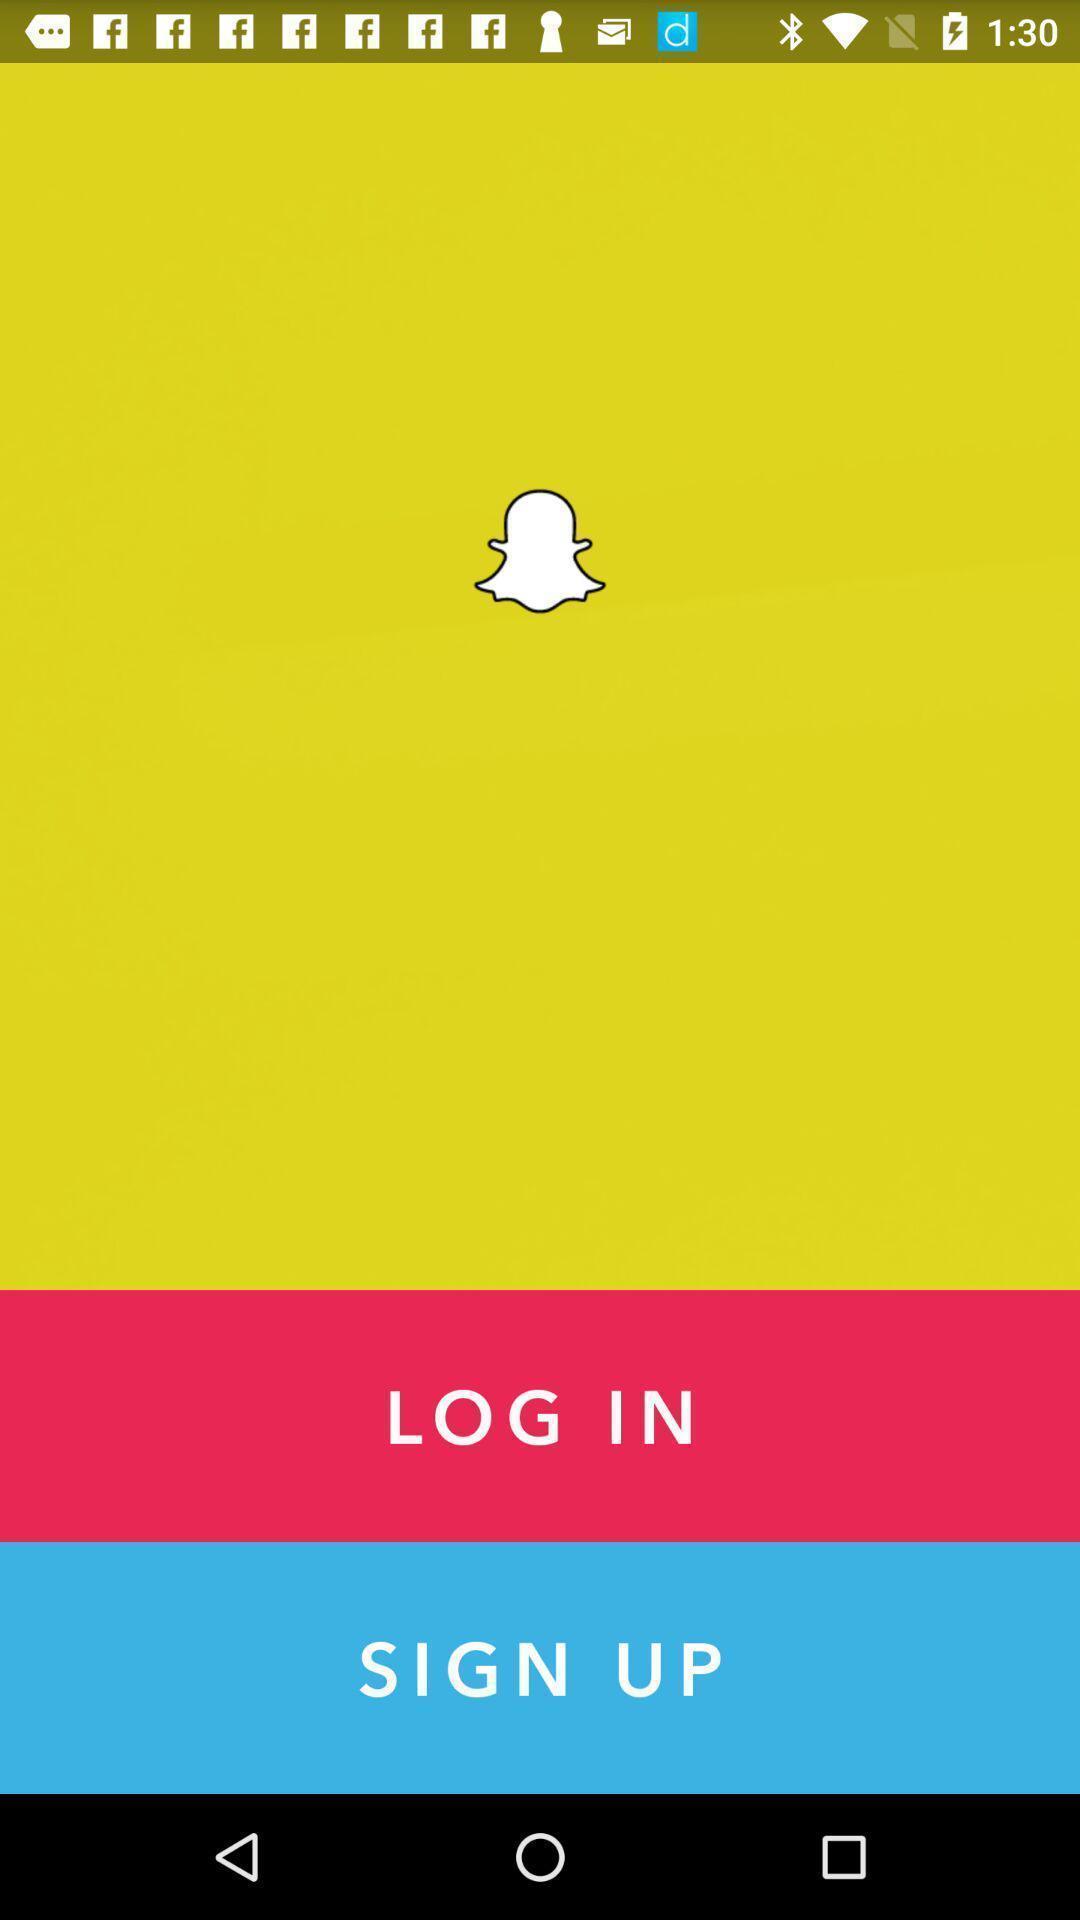Provide a description of this screenshot. Welcome page for an application. 